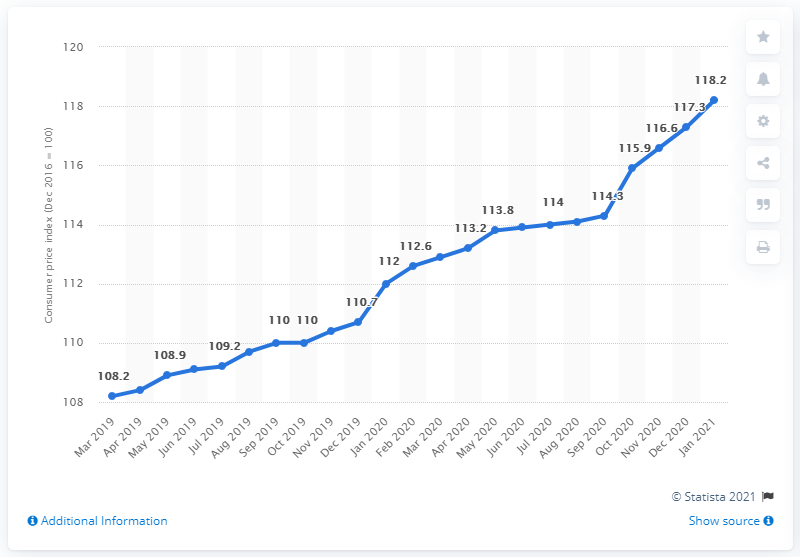Identify some key points in this picture. As of January 2021, the Consumer Price Index in South Africa was 118.2. 